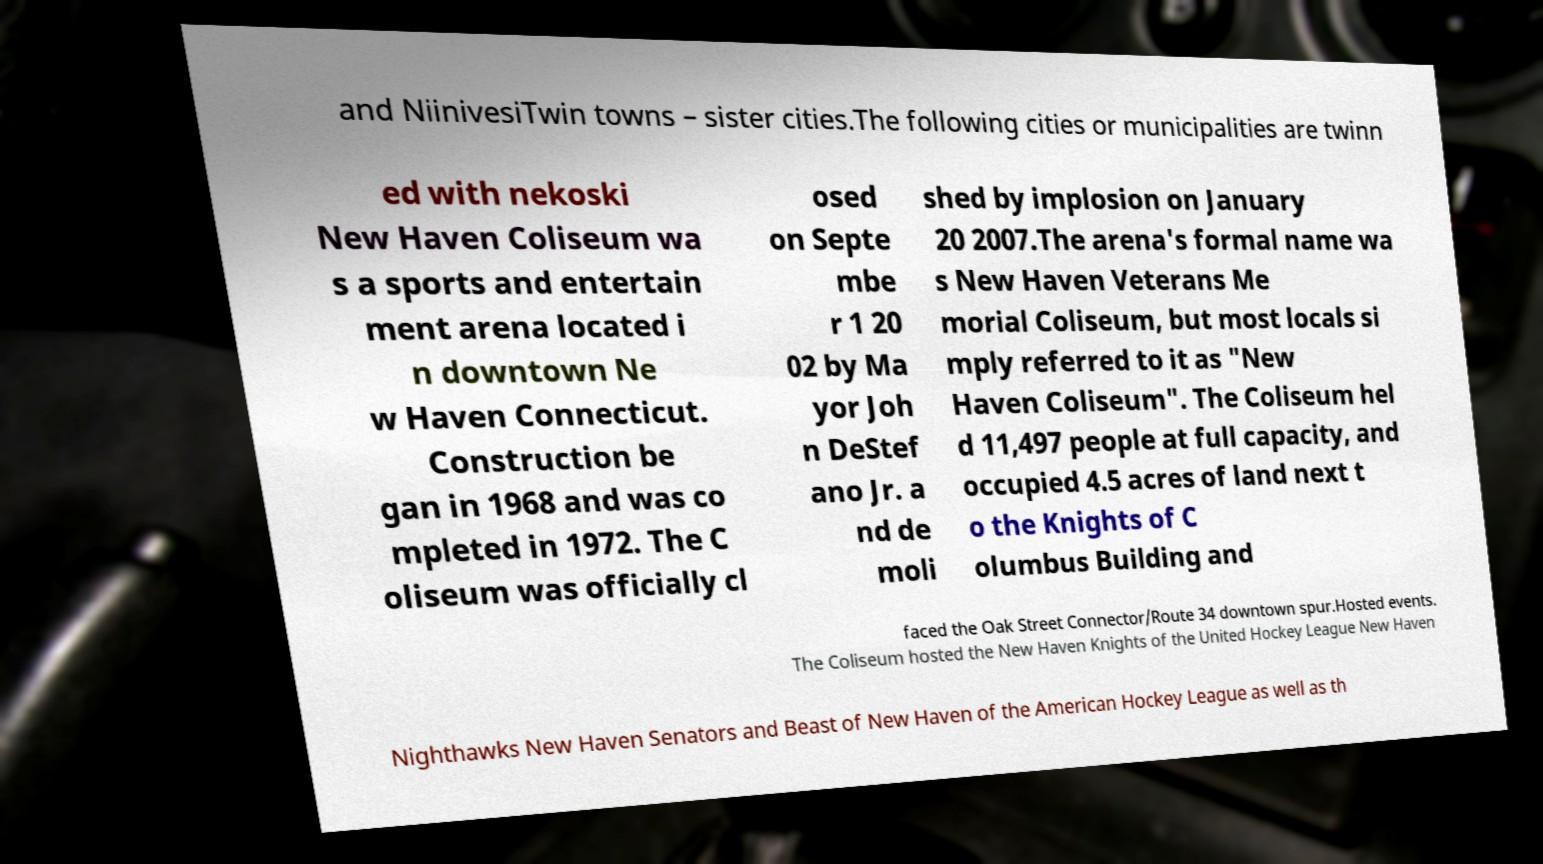Please identify and transcribe the text found in this image. and NiinivesiTwin towns – sister cities.The following cities or municipalities are twinn ed with nekoski New Haven Coliseum wa s a sports and entertain ment arena located i n downtown Ne w Haven Connecticut. Construction be gan in 1968 and was co mpleted in 1972. The C oliseum was officially cl osed on Septe mbe r 1 20 02 by Ma yor Joh n DeStef ano Jr. a nd de moli shed by implosion on January 20 2007.The arena's formal name wa s New Haven Veterans Me morial Coliseum, but most locals si mply referred to it as "New Haven Coliseum". The Coliseum hel d 11,497 people at full capacity, and occupied 4.5 acres of land next t o the Knights of C olumbus Building and faced the Oak Street Connector/Route 34 downtown spur.Hosted events. The Coliseum hosted the New Haven Knights of the United Hockey League New Haven Nighthawks New Haven Senators and Beast of New Haven of the American Hockey League as well as th 